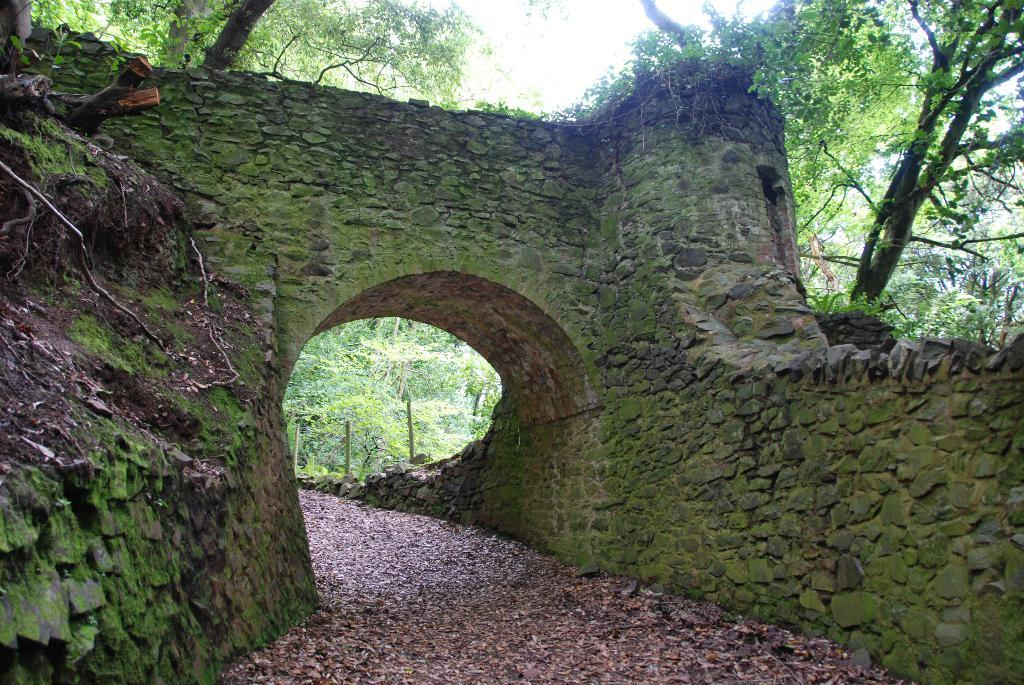What type of structure is present in the image? There is an arch in the image. What type of material is used to construct the walls in the image? There are stone walls in the image. What is growing on the stone walls in the image? The stone walls have algae on them. What can be seen in the background of the image? There are trees in the background of the image. How many chairs are visible in the image? There are no chairs present in the image. What type of plough is being used to cultivate the land in the image? There is no plough present in the image. 